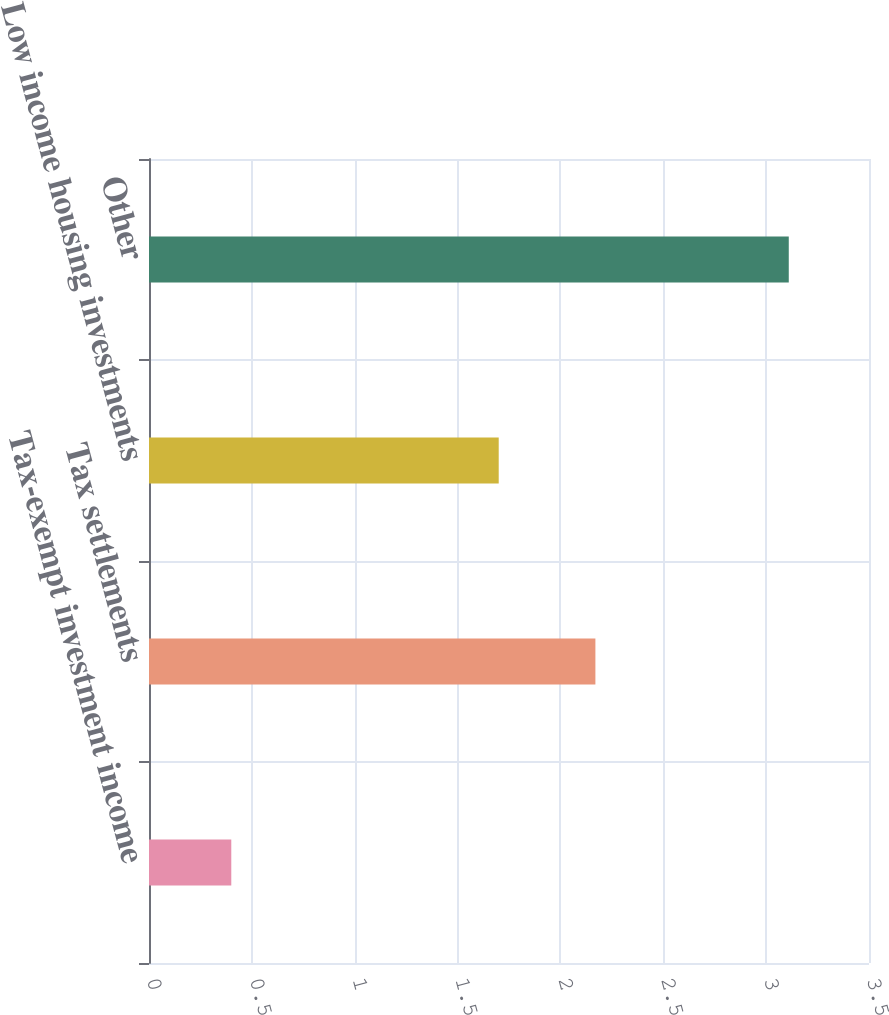Convert chart to OTSL. <chart><loc_0><loc_0><loc_500><loc_500><bar_chart><fcel>Tax-exempt investment income<fcel>Tax settlements<fcel>Low income housing investments<fcel>Other<nl><fcel>0.4<fcel>2.17<fcel>1.7<fcel>3.11<nl></chart> 